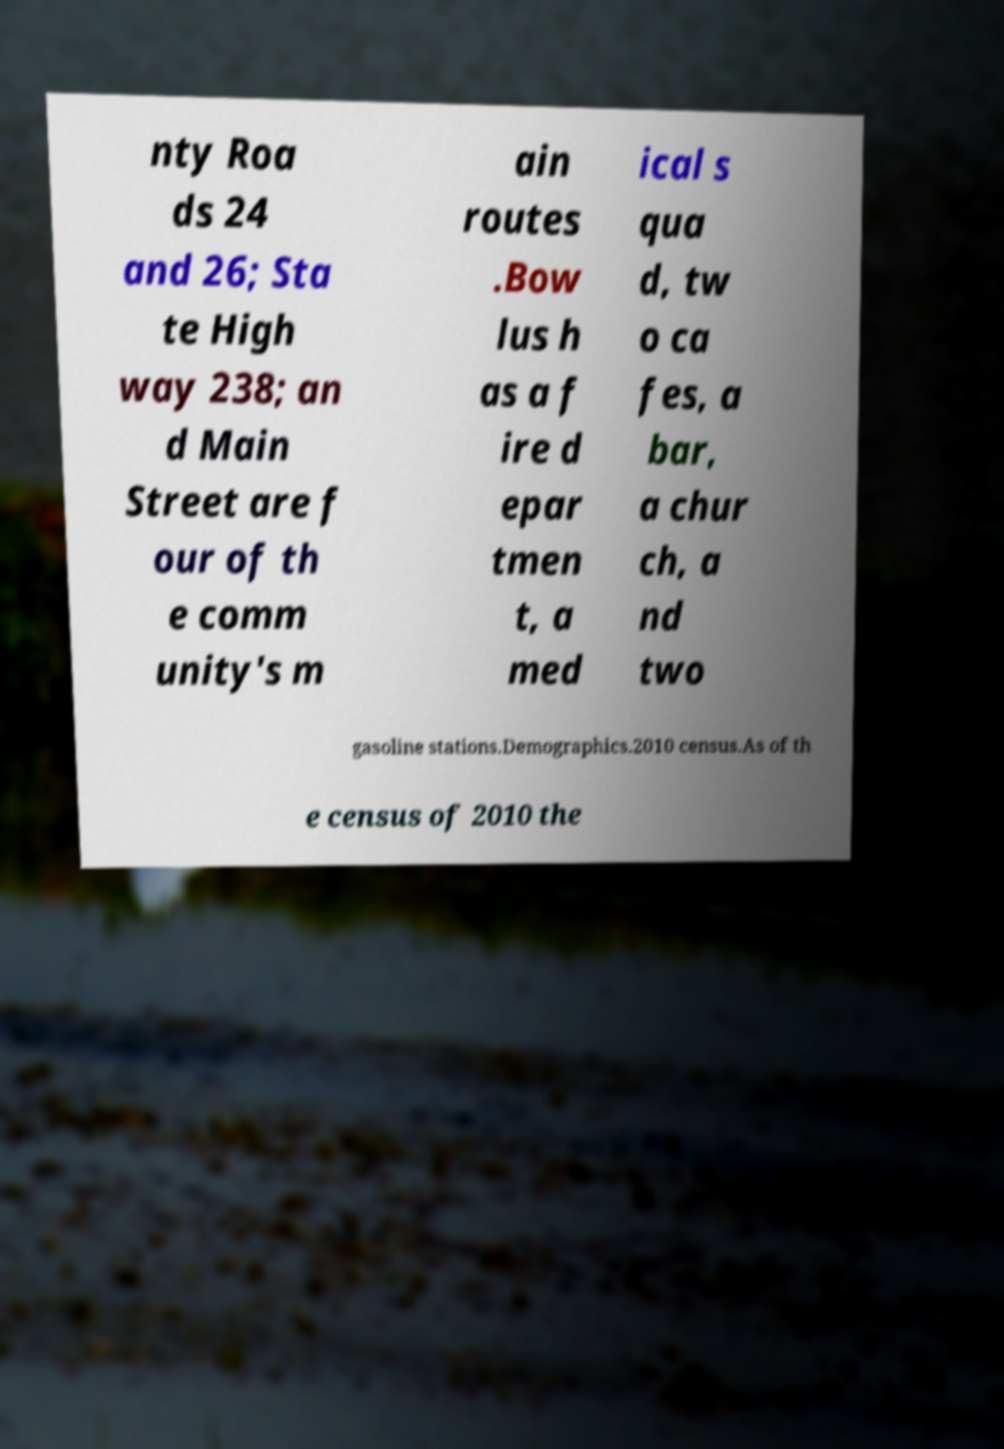For documentation purposes, I need the text within this image transcribed. Could you provide that? nty Roa ds 24 and 26; Sta te High way 238; an d Main Street are f our of th e comm unity's m ain routes .Bow lus h as a f ire d epar tmen t, a med ical s qua d, tw o ca fes, a bar, a chur ch, a nd two gasoline stations.Demographics.2010 census.As of th e census of 2010 the 